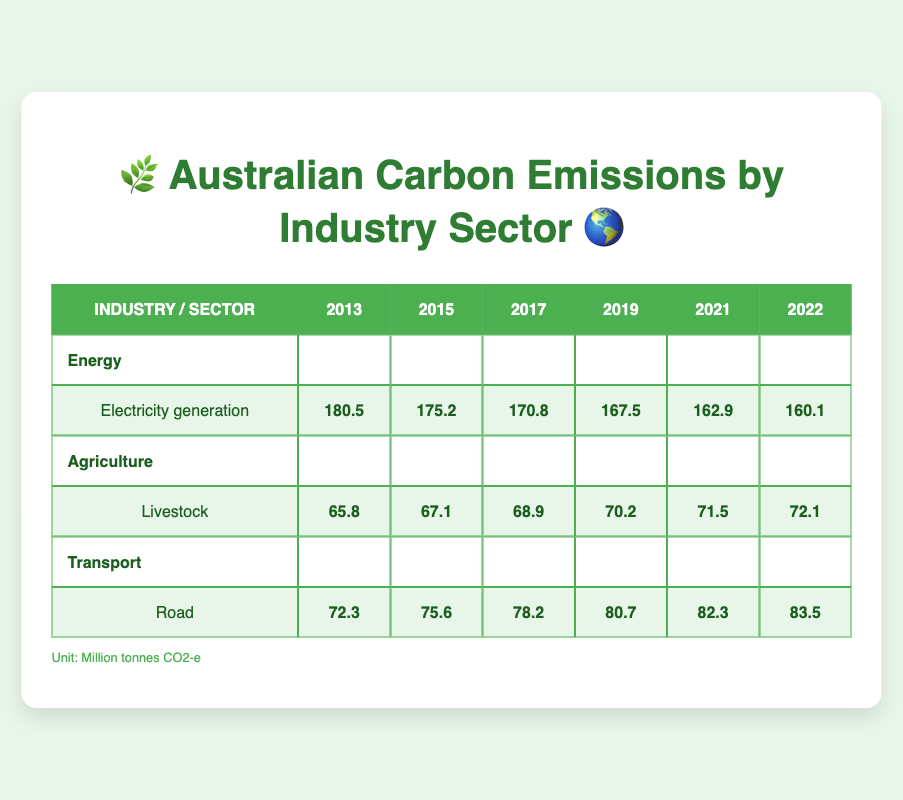What was the carbon emission from the electricity generation sector in 2019? The table shows the emissions for each year and sector. Under the "Energy" industry and "Electricity generation" sector, the emissions for 2019 are listed as 167.5 million tonnes CO2-e.
Answer: 167.5 million tonnes CO2-e Which industry had the highest emissions in 2013? In 2013, the emissions for each industry are listed: Energy (180.5), Agriculture (65.8), and Transport (72.3). The highest value is 180.5 million tonnes CO2-e from the Energy industry.
Answer: Energy What is the total emissions from livestock over all the years shown in the table? The emissions for livestock from 2013 to 2022 are: 65.8, 67.1, 68.9, 70.2, 71.5, and 72.1 million tonnes CO2-e. Summing them up: 65.8 + 67.1 + 68.9 + 70.2 + 71.5 + 72.1 = 415.6 million tonnes CO2-e.
Answer: 415.6 million tonnes CO2-e Did the emissions from the transport sector increase or decrease from 2013 to 2022? The emissions from the transport sector in 2013 were 72.3 million tonnes CO2-e and in 2022 they were 83.5 million tonnes CO2-e. Since 83.5 is greater than 72.3, it indicates an increase over that period.
Answer: Increase What was the average carbon emission from electricity generation between 2013 and 2022? The emissions for electricity generation over the years are: 180.5, 175.2, 170.8, 167.5, 162.9, and 160.1 million tonnes CO2-e. To find the average, first sum these values: 180.5 + 175.2 + 170.8 + 167.5 + 162.9 + 160.1 = 1,017.0 million tonnes CO2-e. There are 6 data points, so dividing 1,017.0 by 6 gives an average of 169.5 million tonnes CO2-e.
Answer: 169.5 million tonnes CO2-e 